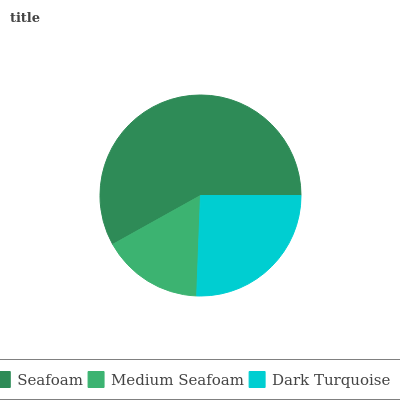Is Medium Seafoam the minimum?
Answer yes or no. Yes. Is Seafoam the maximum?
Answer yes or no. Yes. Is Dark Turquoise the minimum?
Answer yes or no. No. Is Dark Turquoise the maximum?
Answer yes or no. No. Is Dark Turquoise greater than Medium Seafoam?
Answer yes or no. Yes. Is Medium Seafoam less than Dark Turquoise?
Answer yes or no. Yes. Is Medium Seafoam greater than Dark Turquoise?
Answer yes or no. No. Is Dark Turquoise less than Medium Seafoam?
Answer yes or no. No. Is Dark Turquoise the high median?
Answer yes or no. Yes. Is Dark Turquoise the low median?
Answer yes or no. Yes. Is Medium Seafoam the high median?
Answer yes or no. No. Is Seafoam the low median?
Answer yes or no. No. 